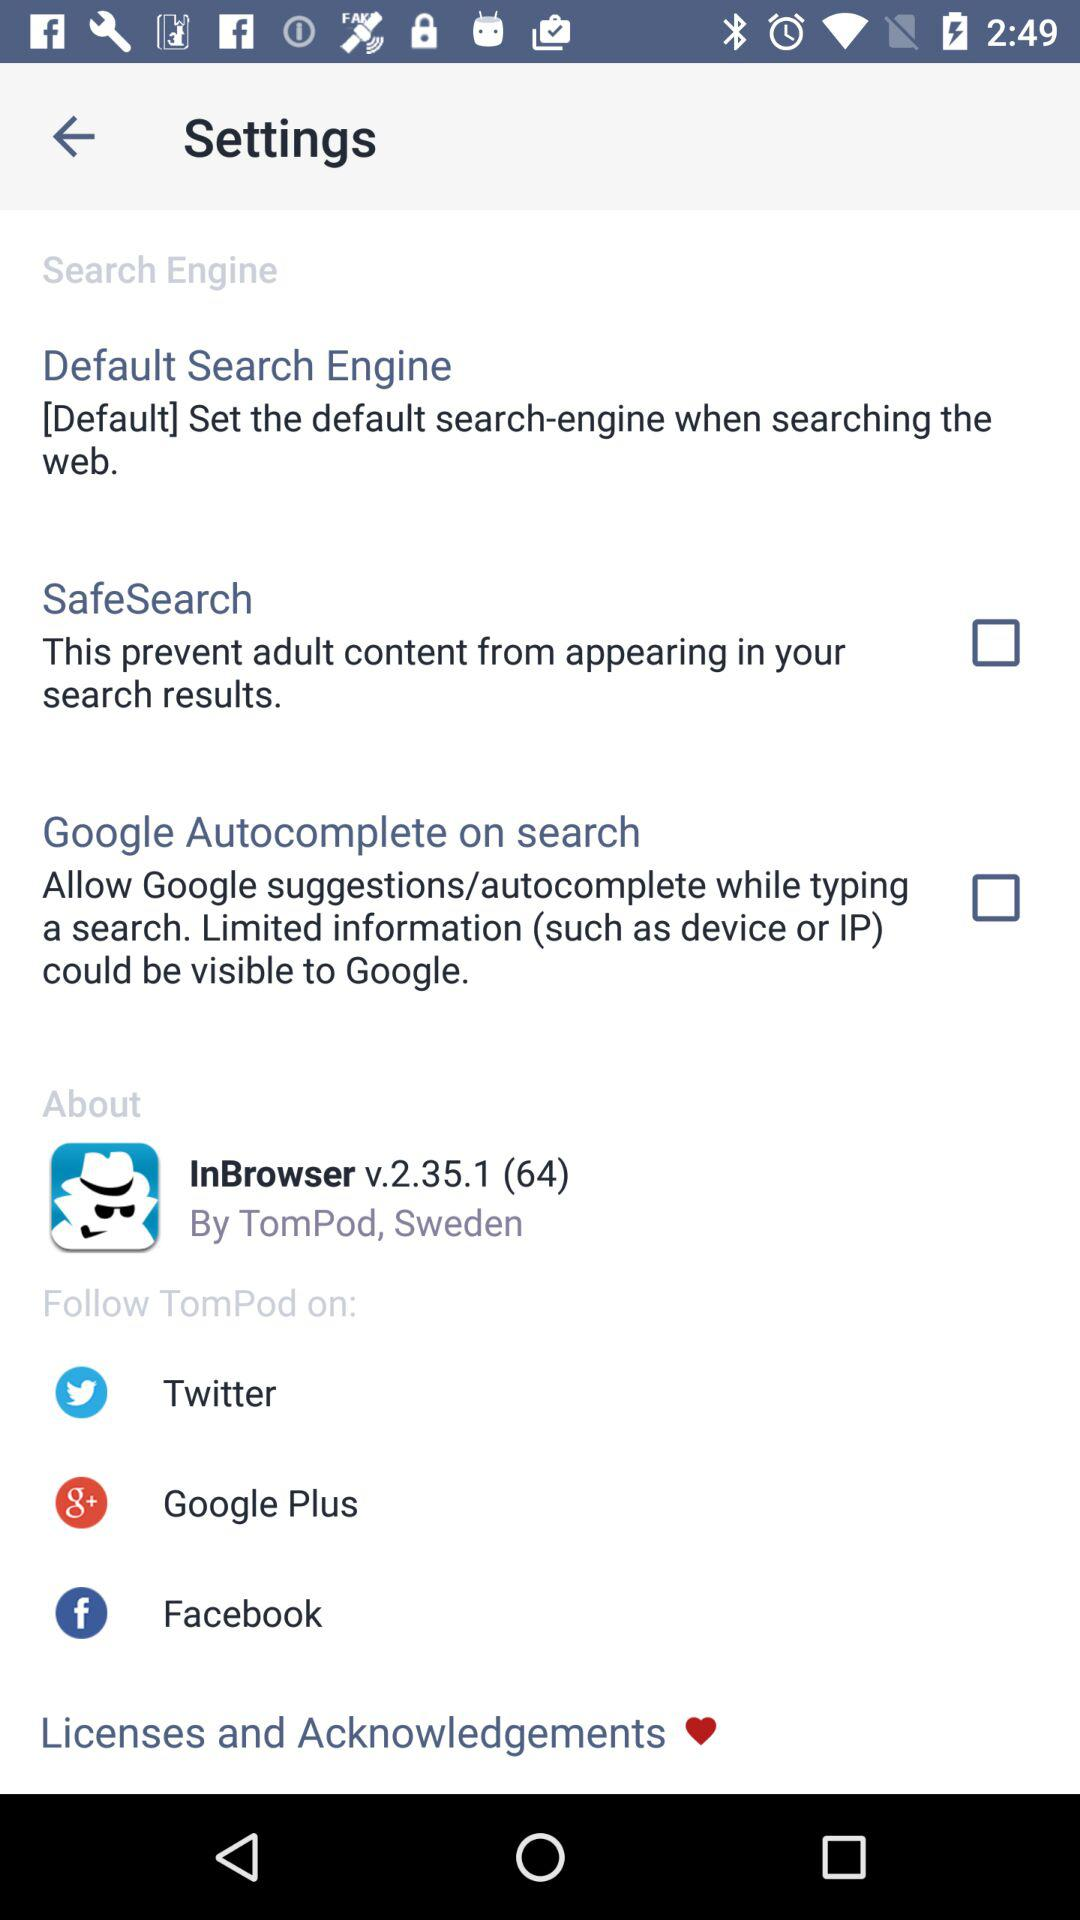What is the version of "InBrowser"? The version is v.2.35.1 (64). 